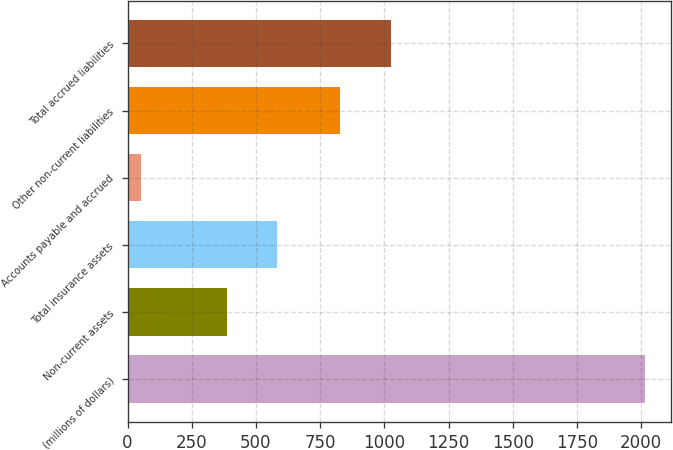Convert chart to OTSL. <chart><loc_0><loc_0><loc_500><loc_500><bar_chart><fcel>(millions of dollars)<fcel>Non-current assets<fcel>Total insurance assets<fcel>Accounts payable and accrued<fcel>Other non-current liabilities<fcel>Total accrued liabilities<nl><fcel>2016<fcel>386.4<fcel>582.83<fcel>51.7<fcel>827.6<fcel>1024.03<nl></chart> 